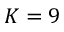Convert formula to latex. <formula><loc_0><loc_0><loc_500><loc_500>K = 9</formula> 